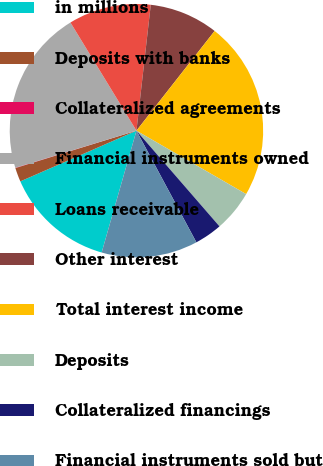Convert chart to OTSL. <chart><loc_0><loc_0><loc_500><loc_500><pie_chart><fcel>in millions<fcel>Deposits with banks<fcel>Collateralized agreements<fcel>Financial instruments owned<fcel>Loans receivable<fcel>Other interest<fcel>Total interest income<fcel>Deposits<fcel>Collateralized financings<fcel>Financial instruments sold but<nl><fcel>14.02%<fcel>1.78%<fcel>0.04%<fcel>21.01%<fcel>10.52%<fcel>8.78%<fcel>22.76%<fcel>5.28%<fcel>3.53%<fcel>12.27%<nl></chart> 